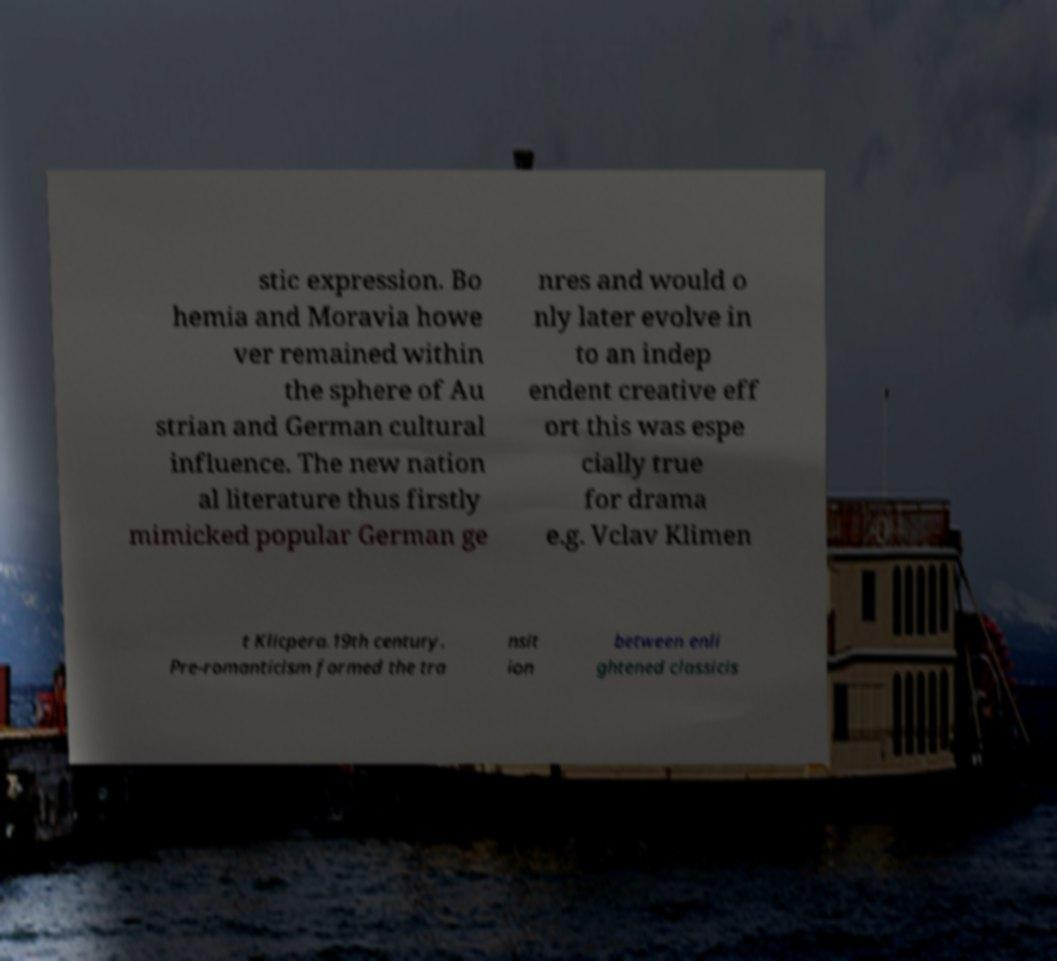What messages or text are displayed in this image? I need them in a readable, typed format. stic expression. Bo hemia and Moravia howe ver remained within the sphere of Au strian and German cultural influence. The new nation al literature thus firstly mimicked popular German ge nres and would o nly later evolve in to an indep endent creative eff ort this was espe cially true for drama e.g. Vclav Klimen t Klicpera.19th century. Pre-romanticism formed the tra nsit ion between enli ghtened classicis 